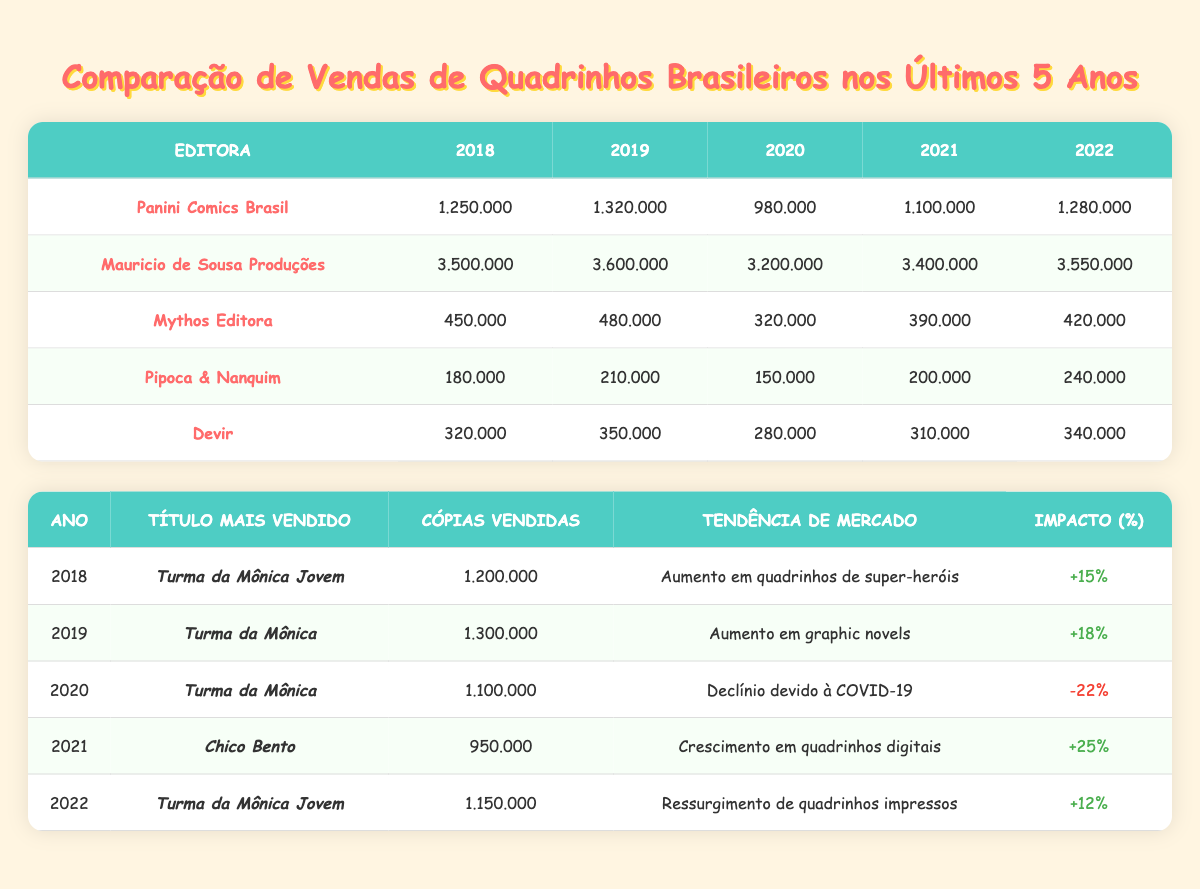What was the highest selling publisher in 2021? In 2021, the sales for each publisher were: Panini Comics Brasil (1,100,000), Mauricio de Sousa Produções (3,400,000), Mythos Editora (390,000), Pipoca & Nanquim (200,000), and Devir (310,000). From this, Mauricio de Sousa Produções had the highest sales at 3,400,000.
Answer: Mauricio de Sousa Produções Which publisher had the lowest sales in 2019? The sales figures for 2019 are: Panini Comics Brasil (1,320,000), Mauricio de Sousa Produções (3,600,000), Mythos Editora (480,000), Pipoca & Nanquim (210,000), and Devir (350,000). The lowest sales among these is for Pipoca & Nanquim at 210,000.
Answer: Pipoca & Nanquim What was the total sales of Mythos Editora over the five years? The sales of Mythos Editora for the years are: 450,000 (2018), 480,000 (2019), 320,000 (2020), 390,000 (2021), and 420,000 (2022). Summing these values gives 450,000 + 480,000 + 320,000 + 390,000 + 420,000 = 2,060,000.
Answer: 2,060,000 Did sales for Panini Comics Brasil decrease from 2019 to 2020? The sales for Panini Comics Brasil were 1,320,000 in 2019 and dropped to 980,000 in 2020. Since 980,000 is less than 1,320,000, this indicates a decrease in sales for this publisher.
Answer: Yes What year experienced the highest increase in market trends based on impact percentage? The impact percentages for market trends show: 2018 (+15%), 2019 (+18%), 2020 (-22%), 2021 (+25%), and 2022 (+12%). The highest increase is in 2021 with an impact percentage of +25%.
Answer: 2021 What was the average sales for Mauricio de Sousa Produções over the five years? The sales for Mauricio de Sousa Produções are: 3,500,000 (2018), 3,600,000 (2019), 3,200,000 (2020), 3,400,000 (2021), and 3,550,000 (2022). The average is calculated by summing them up: 3,500,000 + 3,600,000 + 3,200,000 + 3,400,000 + 3,550,000 = 17,250,000, then dividing by 5, which gives 17,250,000 / 5 = 3,450,000.
Answer: 3,450,000 Which title was the top seller in 2020? The table indicates that in 2020, the title "Turma da Mônica" was the top seller with 1,100,000 copies sold.
Answer: Turma da Mônica How did the trend in 2021 compare to the trend in 2020? The trend in 2020 was a decline due to COVID-19 with an impact of -22%. In contrast, the trend in 2021 was a growth in digital comics with an impact of +25%. This indicates a significant recovery and positive growth after the decline in the previous year.
Answer: Significant Recovery 